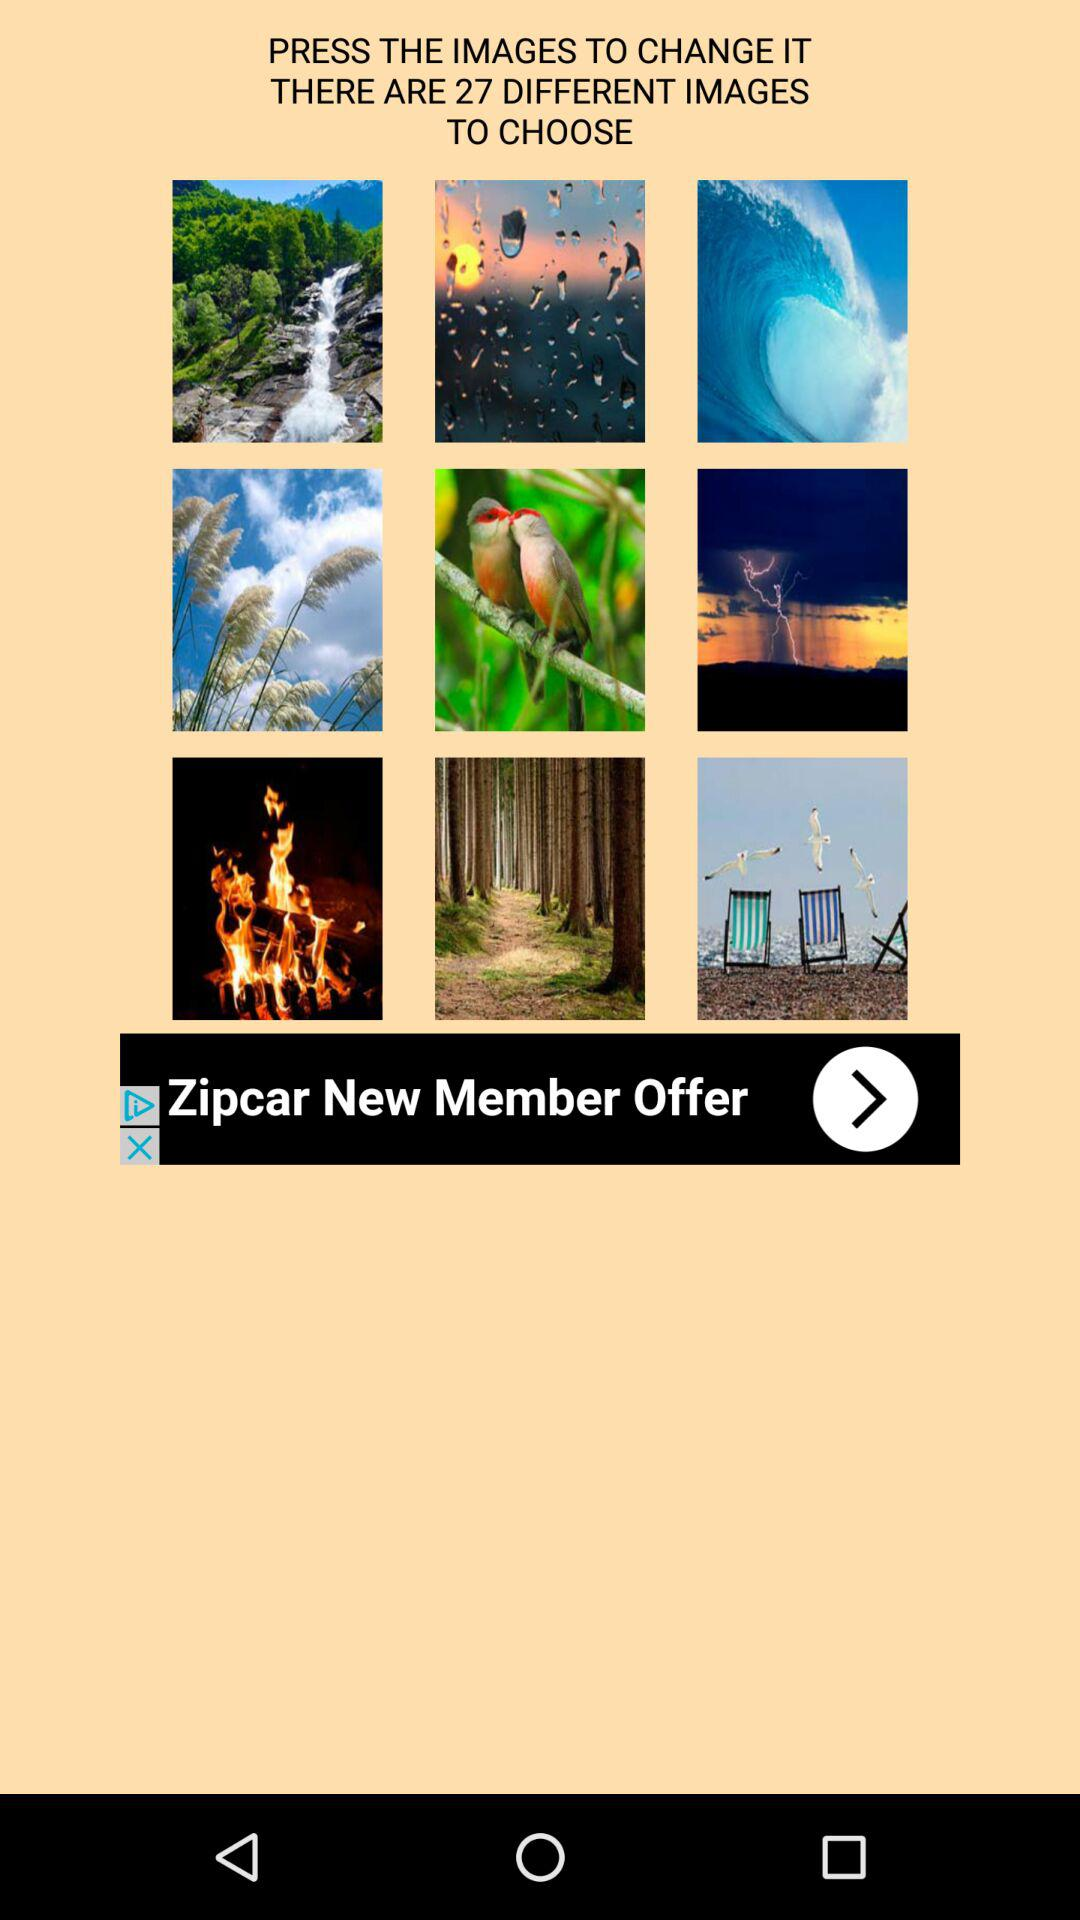How many photos do we have to choose from? You have 27 photos to choose from. 